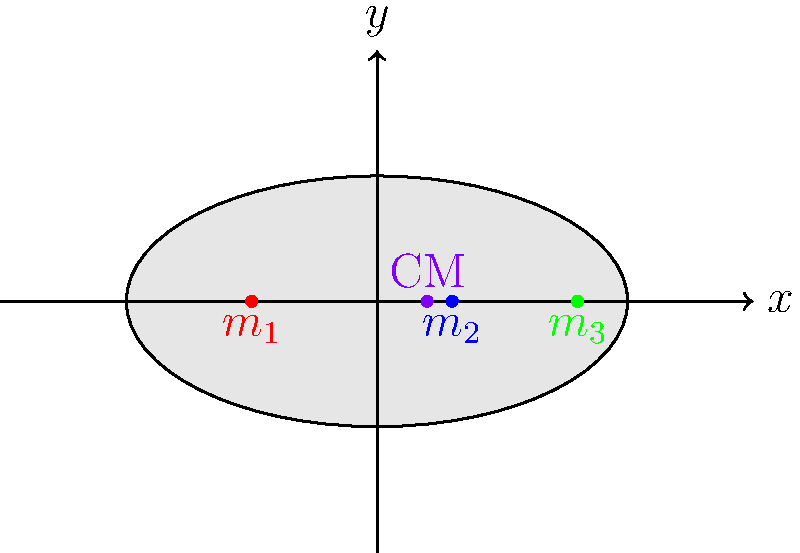In a lawn bowl used for the World Bowls Championships, the mass is not uniformly distributed. Consider a simplified model where the bowl has three concentrated masses along its x-axis: $m_1 = 0.6$ kg at $x_1 = -0.5$ m, $m_2 = 0.8$ kg at $x_2 = 0.3$ m, and $m_3 = 0.4$ kg at $x_3 = 0.8$ m. Calculate the x-coordinate of the center of mass for this lawn bowl. To find the center of mass for a system of discrete masses along a single axis, we can use the formula:

$$x_{CM} = \frac{\sum_{i} m_i x_i}{\sum_{i} m_i}$$

Where $x_{CM}$ is the x-coordinate of the center of mass, $m_i$ are the individual masses, and $x_i$ are their respective positions along the x-axis.

Let's follow these steps:

1) First, let's calculate the numerator $\sum_{i} m_i x_i$:
   $$m_1 x_1 + m_2 x_2 + m_3 x_3 = (0.6 \times -0.5) + (0.8 \times 0.3) + (0.4 \times 0.8)$$
   $$= -0.3 + 0.24 + 0.32 = 0.26 \text{ kg}\cdot\text{m}$$

2) Now, let's calculate the denominator $\sum_{i} m_i$:
   $$m_1 + m_2 + m_3 = 0.6 + 0.8 + 0.4 = 1.8 \text{ kg}$$

3) Finally, we can calculate $x_{CM}$:
   $$x_{CM} = \frac{0.26 \text{ kg}\cdot\text{m}}{1.8 \text{ kg}} = 0.144444... \text{ m}$$

4) Rounding to two decimal places, we get:
   $$x_{CM} \approx 0.14 \text{ m}$$

This result matches the approximate position of the center of mass (CM) shown in the diagram.
Answer: 0.14 m 